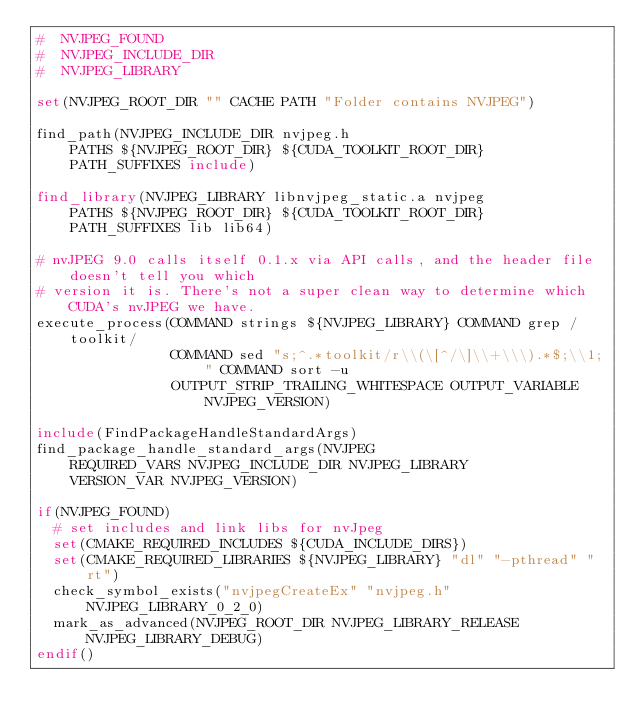Convert code to text. <code><loc_0><loc_0><loc_500><loc_500><_CMake_>#  NVJPEG_FOUND
#  NVJPEG_INCLUDE_DIR
#  NVJPEG_LIBRARY

set(NVJPEG_ROOT_DIR "" CACHE PATH "Folder contains NVJPEG")

find_path(NVJPEG_INCLUDE_DIR nvjpeg.h
    PATHS ${NVJPEG_ROOT_DIR} ${CUDA_TOOLKIT_ROOT_DIR}
    PATH_SUFFIXES include)

find_library(NVJPEG_LIBRARY libnvjpeg_static.a nvjpeg
    PATHS ${NVJPEG_ROOT_DIR} ${CUDA_TOOLKIT_ROOT_DIR}
    PATH_SUFFIXES lib lib64)

# nvJPEG 9.0 calls itself 0.1.x via API calls, and the header file doesn't tell you which
# version it is. There's not a super clean way to determine which CUDA's nvJPEG we have.
execute_process(COMMAND strings ${NVJPEG_LIBRARY} COMMAND grep /toolkit/
                COMMAND sed "s;^.*toolkit/r\\(\[^/\]\\+\\\).*$;\\1;" COMMAND sort -u
                OUTPUT_STRIP_TRAILING_WHITESPACE OUTPUT_VARIABLE NVJPEG_VERSION)

include(FindPackageHandleStandardArgs)
find_package_handle_standard_args(NVJPEG
    REQUIRED_VARS NVJPEG_INCLUDE_DIR NVJPEG_LIBRARY
    VERSION_VAR NVJPEG_VERSION)

if(NVJPEG_FOUND)
  # set includes and link libs for nvJpeg
  set(CMAKE_REQUIRED_INCLUDES ${CUDA_INCLUDE_DIRS})
  set(CMAKE_REQUIRED_LIBRARIES ${NVJPEG_LIBRARY} "dl" "-pthread" "rt")
  check_symbol_exists("nvjpegCreateEx" "nvjpeg.h" NVJPEG_LIBRARY_0_2_0)
  mark_as_advanced(NVJPEG_ROOT_DIR NVJPEG_LIBRARY_RELEASE NVJPEG_LIBRARY_DEBUG)
endif()
</code> 